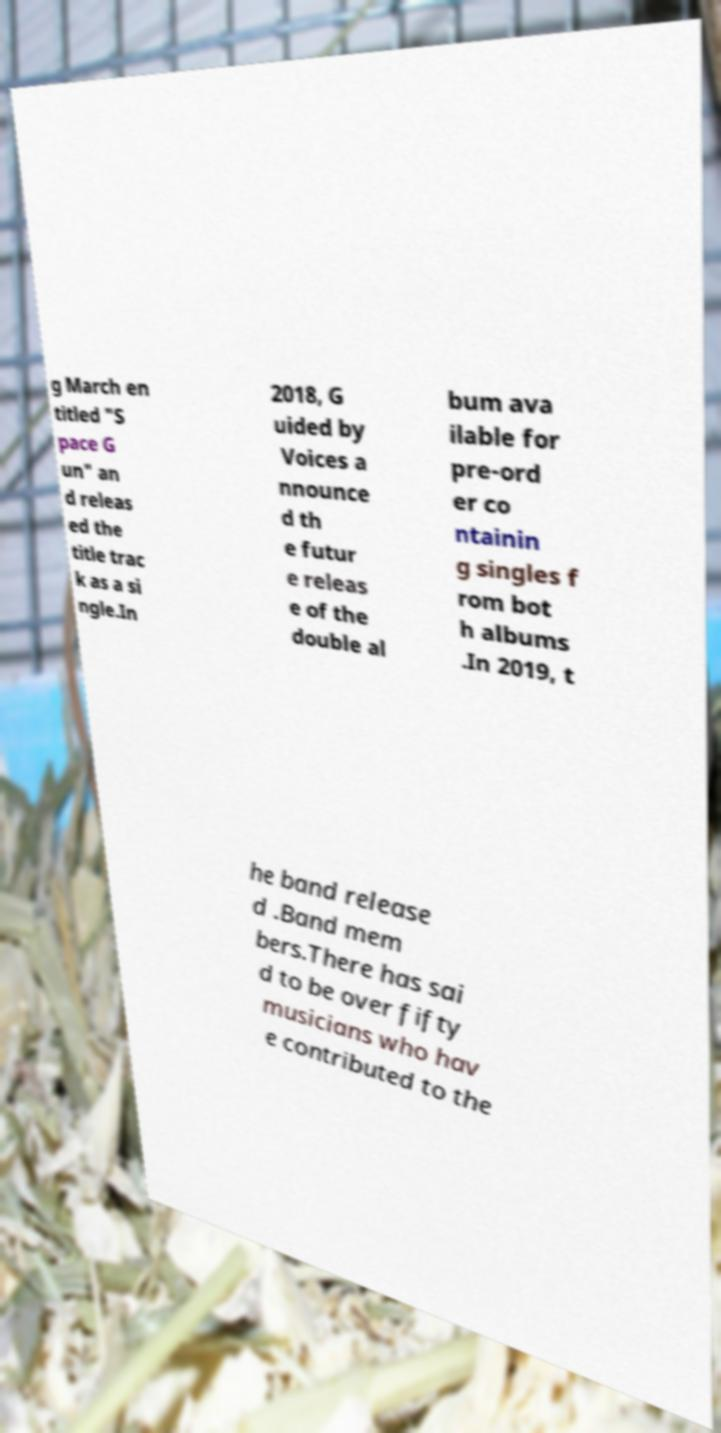For documentation purposes, I need the text within this image transcribed. Could you provide that? g March en titled "S pace G un" an d releas ed the title trac k as a si ngle.In 2018, G uided by Voices a nnounce d th e futur e releas e of the double al bum ava ilable for pre-ord er co ntainin g singles f rom bot h albums .In 2019, t he band release d .Band mem bers.There has sai d to be over fifty musicians who hav e contributed to the 